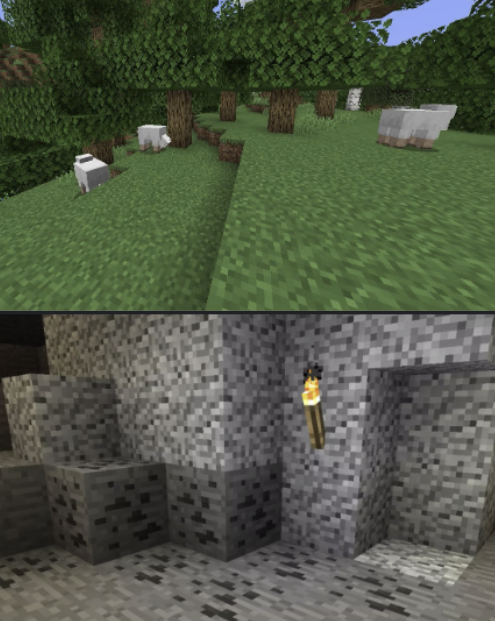You are a Minecraft Player. Your current high-level task is: 'mine redstone'. Your current low-level task is: 'find a creeper'. Your inventory has the following in it: nothing.

First, critique your low-level task in light of your high-level task, keeping your inventory in mind. If it is not the appropriate low-level task, please suggest a different one -- if you do, proceed with the assumption that your current low-level task is the one you suggested.

There are two scenes provided, top and bottom. Please describe them both, as though you were trying to convey the image to a blind person. Be specific, but don't give unnecessary emotional descriptions. For instance, if the image were of a forest biome, "a lush verdant forest, beautiful and pleasing to the eye" would be a bad description; a better description would be "A forest biome. You see many birch trees. There is a sheep in the distance. There is one sapling on the ground. It is daytime." In your final description, take note of any details that may be relevant to your current low-level task.

Then, rate the desirability of both scenes, given your current tasks and inventory. Explain your reasoning, and indicate which scene you prefer. Your response MUST include one of the following phrases: "I prefer the top"; "I prefer the bottom"; or, in the case where both are equally preferable (or equally bad) "I prefer neither". The low-level task, "find a creeper", is not the most appropriate given the high-level task of "mine redstone". Creepers are hostile mobs that are found in the Overworld. They are not typically found in caves, which is where redstone is found. A more appropriate low-level task would be "find a cave".

The top scene is a forest biome. There are many birch trees, sheep, and tall grass. It is daytime. The bottom scene is a cave. There is a stone wall with a torch on it. There is a cobblestone floor. It is dark.

I prefer the bottom scene. It is more likely to contain redstone, which is the goal of my high-level task. The top scene is less likely to contain redstone, and it is also more dangerous due to the presence of hostile mobs. 